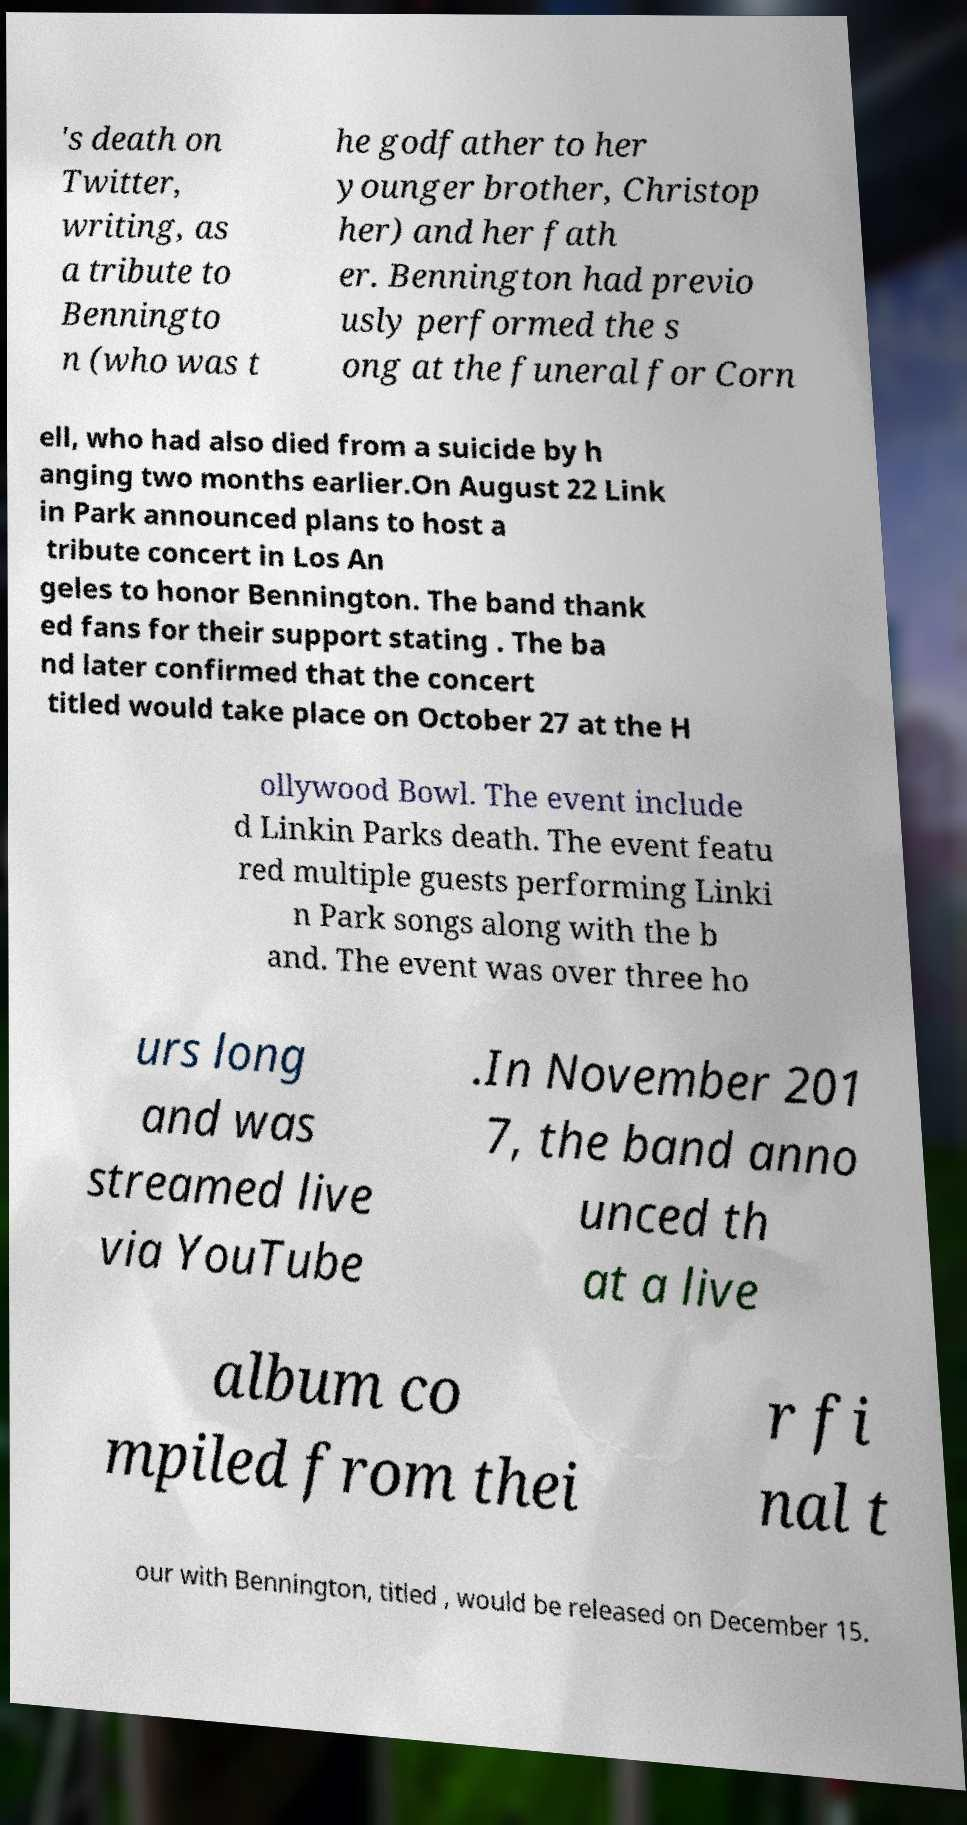What messages or text are displayed in this image? I need them in a readable, typed format. 's death on Twitter, writing, as a tribute to Benningto n (who was t he godfather to her younger brother, Christop her) and her fath er. Bennington had previo usly performed the s ong at the funeral for Corn ell, who had also died from a suicide by h anging two months earlier.On August 22 Link in Park announced plans to host a tribute concert in Los An geles to honor Bennington. The band thank ed fans for their support stating . The ba nd later confirmed that the concert titled would take place on October 27 at the H ollywood Bowl. The event include d Linkin Parks death. The event featu red multiple guests performing Linki n Park songs along with the b and. The event was over three ho urs long and was streamed live via YouTube .In November 201 7, the band anno unced th at a live album co mpiled from thei r fi nal t our with Bennington, titled , would be released on December 15. 